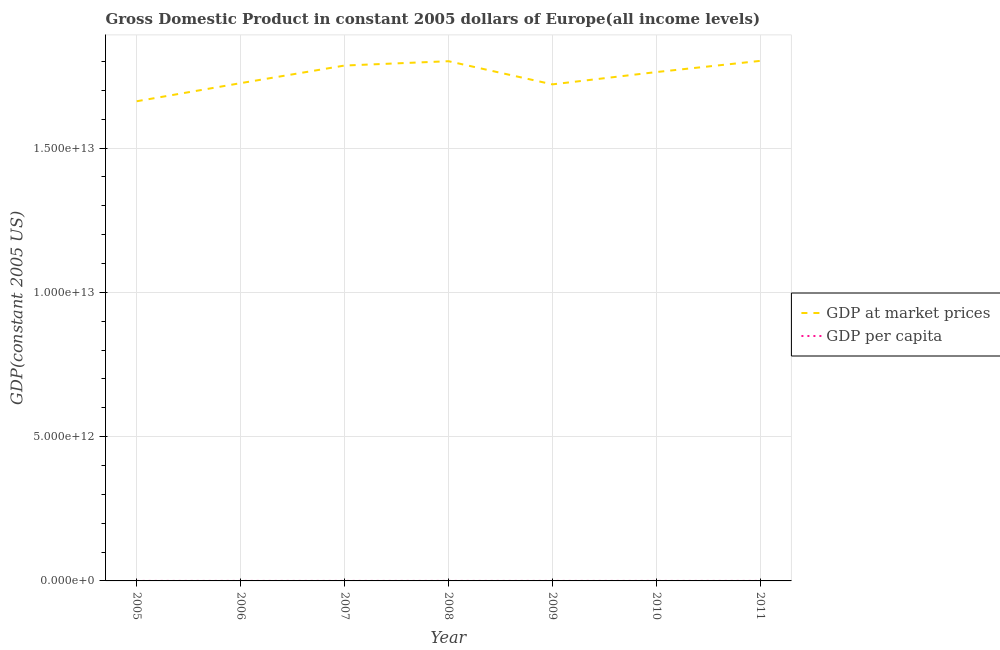How many different coloured lines are there?
Your response must be concise. 2. What is the gdp at market prices in 2008?
Offer a terse response. 1.80e+13. Across all years, what is the maximum gdp per capita?
Provide a short and direct response. 2.04e+04. Across all years, what is the minimum gdp per capita?
Offer a very short reply. 1.90e+04. In which year was the gdp per capita maximum?
Provide a succinct answer. 2008. In which year was the gdp at market prices minimum?
Offer a terse response. 2005. What is the total gdp per capita in the graph?
Offer a terse response. 1.39e+05. What is the difference between the gdp per capita in 2009 and that in 2011?
Your answer should be compact. -758.73. What is the difference between the gdp per capita in 2010 and the gdp at market prices in 2011?
Offer a very short reply. -1.80e+13. What is the average gdp per capita per year?
Make the answer very short. 1.98e+04. In the year 2005, what is the difference between the gdp per capita and gdp at market prices?
Ensure brevity in your answer.  -1.66e+13. In how many years, is the gdp at market prices greater than 7000000000000 US$?
Keep it short and to the point. 7. What is the ratio of the gdp at market prices in 2005 to that in 2010?
Your answer should be compact. 0.94. Is the gdp per capita in 2007 less than that in 2008?
Make the answer very short. Yes. What is the difference between the highest and the second highest gdp at market prices?
Ensure brevity in your answer.  1.16e+1. What is the difference between the highest and the lowest gdp at market prices?
Make the answer very short. 1.40e+12. Is the gdp at market prices strictly greater than the gdp per capita over the years?
Your answer should be compact. Yes. Is the gdp per capita strictly less than the gdp at market prices over the years?
Keep it short and to the point. Yes. How many years are there in the graph?
Your response must be concise. 7. What is the difference between two consecutive major ticks on the Y-axis?
Provide a succinct answer. 5.00e+12. Where does the legend appear in the graph?
Provide a succinct answer. Center right. What is the title of the graph?
Your answer should be very brief. Gross Domestic Product in constant 2005 dollars of Europe(all income levels). Does "Imports" appear as one of the legend labels in the graph?
Give a very brief answer. No. What is the label or title of the X-axis?
Your response must be concise. Year. What is the label or title of the Y-axis?
Your answer should be compact. GDP(constant 2005 US). What is the GDP(constant 2005 US) of GDP at market prices in 2005?
Offer a very short reply. 1.66e+13. What is the GDP(constant 2005 US) of GDP per capita in 2005?
Make the answer very short. 1.90e+04. What is the GDP(constant 2005 US) of GDP at market prices in 2006?
Give a very brief answer. 1.73e+13. What is the GDP(constant 2005 US) in GDP per capita in 2006?
Your answer should be very brief. 1.97e+04. What is the GDP(constant 2005 US) of GDP at market prices in 2007?
Your answer should be very brief. 1.79e+13. What is the GDP(constant 2005 US) in GDP per capita in 2007?
Keep it short and to the point. 2.03e+04. What is the GDP(constant 2005 US) of GDP at market prices in 2008?
Your answer should be compact. 1.80e+13. What is the GDP(constant 2005 US) in GDP per capita in 2008?
Offer a terse response. 2.04e+04. What is the GDP(constant 2005 US) of GDP at market prices in 2009?
Your answer should be compact. 1.72e+13. What is the GDP(constant 2005 US) of GDP per capita in 2009?
Provide a succinct answer. 1.94e+04. What is the GDP(constant 2005 US) of GDP at market prices in 2010?
Your answer should be compact. 1.76e+13. What is the GDP(constant 2005 US) of GDP per capita in 2010?
Keep it short and to the point. 1.98e+04. What is the GDP(constant 2005 US) of GDP at market prices in 2011?
Your answer should be very brief. 1.80e+13. What is the GDP(constant 2005 US) of GDP per capita in 2011?
Make the answer very short. 2.02e+04. Across all years, what is the maximum GDP(constant 2005 US) in GDP at market prices?
Offer a very short reply. 1.80e+13. Across all years, what is the maximum GDP(constant 2005 US) of GDP per capita?
Ensure brevity in your answer.  2.04e+04. Across all years, what is the minimum GDP(constant 2005 US) in GDP at market prices?
Offer a terse response. 1.66e+13. Across all years, what is the minimum GDP(constant 2005 US) of GDP per capita?
Keep it short and to the point. 1.90e+04. What is the total GDP(constant 2005 US) of GDP at market prices in the graph?
Offer a terse response. 1.23e+14. What is the total GDP(constant 2005 US) of GDP per capita in the graph?
Offer a terse response. 1.39e+05. What is the difference between the GDP(constant 2005 US) of GDP at market prices in 2005 and that in 2006?
Provide a succinct answer. -6.28e+11. What is the difference between the GDP(constant 2005 US) in GDP per capita in 2005 and that in 2006?
Your response must be concise. -656.02. What is the difference between the GDP(constant 2005 US) of GDP at market prices in 2005 and that in 2007?
Offer a terse response. -1.24e+12. What is the difference between the GDP(constant 2005 US) of GDP per capita in 2005 and that in 2007?
Your response must be concise. -1281.47. What is the difference between the GDP(constant 2005 US) of GDP at market prices in 2005 and that in 2008?
Make the answer very short. -1.39e+12. What is the difference between the GDP(constant 2005 US) of GDP per capita in 2005 and that in 2008?
Offer a terse response. -1369.71. What is the difference between the GDP(constant 2005 US) of GDP at market prices in 2005 and that in 2009?
Provide a short and direct response. -5.85e+11. What is the difference between the GDP(constant 2005 US) of GDP per capita in 2005 and that in 2009?
Provide a short and direct response. -378.62. What is the difference between the GDP(constant 2005 US) of GDP at market prices in 2005 and that in 2010?
Your answer should be very brief. -1.01e+12. What is the difference between the GDP(constant 2005 US) of GDP per capita in 2005 and that in 2010?
Your answer should be very brief. -780.19. What is the difference between the GDP(constant 2005 US) of GDP at market prices in 2005 and that in 2011?
Your answer should be very brief. -1.40e+12. What is the difference between the GDP(constant 2005 US) of GDP per capita in 2005 and that in 2011?
Your answer should be very brief. -1137.34. What is the difference between the GDP(constant 2005 US) in GDP at market prices in 2006 and that in 2007?
Your response must be concise. -6.10e+11. What is the difference between the GDP(constant 2005 US) of GDP per capita in 2006 and that in 2007?
Offer a very short reply. -625.44. What is the difference between the GDP(constant 2005 US) of GDP at market prices in 2006 and that in 2008?
Give a very brief answer. -7.60e+11. What is the difference between the GDP(constant 2005 US) of GDP per capita in 2006 and that in 2008?
Provide a succinct answer. -713.69. What is the difference between the GDP(constant 2005 US) in GDP at market prices in 2006 and that in 2009?
Your answer should be very brief. 4.28e+1. What is the difference between the GDP(constant 2005 US) in GDP per capita in 2006 and that in 2009?
Make the answer very short. 277.41. What is the difference between the GDP(constant 2005 US) in GDP at market prices in 2006 and that in 2010?
Provide a short and direct response. -3.84e+11. What is the difference between the GDP(constant 2005 US) of GDP per capita in 2006 and that in 2010?
Keep it short and to the point. -124.16. What is the difference between the GDP(constant 2005 US) of GDP at market prices in 2006 and that in 2011?
Make the answer very short. -7.71e+11. What is the difference between the GDP(constant 2005 US) in GDP per capita in 2006 and that in 2011?
Your answer should be very brief. -481.32. What is the difference between the GDP(constant 2005 US) of GDP at market prices in 2007 and that in 2008?
Keep it short and to the point. -1.50e+11. What is the difference between the GDP(constant 2005 US) of GDP per capita in 2007 and that in 2008?
Offer a terse response. -88.25. What is the difference between the GDP(constant 2005 US) of GDP at market prices in 2007 and that in 2009?
Keep it short and to the point. 6.53e+11. What is the difference between the GDP(constant 2005 US) in GDP per capita in 2007 and that in 2009?
Offer a very short reply. 902.85. What is the difference between the GDP(constant 2005 US) in GDP at market prices in 2007 and that in 2010?
Provide a succinct answer. 2.26e+11. What is the difference between the GDP(constant 2005 US) in GDP per capita in 2007 and that in 2010?
Offer a terse response. 501.28. What is the difference between the GDP(constant 2005 US) in GDP at market prices in 2007 and that in 2011?
Keep it short and to the point. -1.61e+11. What is the difference between the GDP(constant 2005 US) in GDP per capita in 2007 and that in 2011?
Your response must be concise. 144.12. What is the difference between the GDP(constant 2005 US) of GDP at market prices in 2008 and that in 2009?
Offer a very short reply. 8.03e+11. What is the difference between the GDP(constant 2005 US) in GDP per capita in 2008 and that in 2009?
Your answer should be compact. 991.1. What is the difference between the GDP(constant 2005 US) of GDP at market prices in 2008 and that in 2010?
Your answer should be compact. 3.76e+11. What is the difference between the GDP(constant 2005 US) of GDP per capita in 2008 and that in 2010?
Provide a short and direct response. 589.53. What is the difference between the GDP(constant 2005 US) in GDP at market prices in 2008 and that in 2011?
Offer a very short reply. -1.16e+1. What is the difference between the GDP(constant 2005 US) in GDP per capita in 2008 and that in 2011?
Your response must be concise. 232.37. What is the difference between the GDP(constant 2005 US) in GDP at market prices in 2009 and that in 2010?
Offer a terse response. -4.27e+11. What is the difference between the GDP(constant 2005 US) of GDP per capita in 2009 and that in 2010?
Your answer should be compact. -401.57. What is the difference between the GDP(constant 2005 US) in GDP at market prices in 2009 and that in 2011?
Ensure brevity in your answer.  -8.14e+11. What is the difference between the GDP(constant 2005 US) in GDP per capita in 2009 and that in 2011?
Make the answer very short. -758.73. What is the difference between the GDP(constant 2005 US) in GDP at market prices in 2010 and that in 2011?
Offer a terse response. -3.88e+11. What is the difference between the GDP(constant 2005 US) in GDP per capita in 2010 and that in 2011?
Give a very brief answer. -357.16. What is the difference between the GDP(constant 2005 US) of GDP at market prices in 2005 and the GDP(constant 2005 US) of GDP per capita in 2006?
Provide a short and direct response. 1.66e+13. What is the difference between the GDP(constant 2005 US) of GDP at market prices in 2005 and the GDP(constant 2005 US) of GDP per capita in 2007?
Keep it short and to the point. 1.66e+13. What is the difference between the GDP(constant 2005 US) of GDP at market prices in 2005 and the GDP(constant 2005 US) of GDP per capita in 2008?
Your answer should be compact. 1.66e+13. What is the difference between the GDP(constant 2005 US) in GDP at market prices in 2005 and the GDP(constant 2005 US) in GDP per capita in 2009?
Provide a short and direct response. 1.66e+13. What is the difference between the GDP(constant 2005 US) of GDP at market prices in 2005 and the GDP(constant 2005 US) of GDP per capita in 2010?
Provide a short and direct response. 1.66e+13. What is the difference between the GDP(constant 2005 US) of GDP at market prices in 2005 and the GDP(constant 2005 US) of GDP per capita in 2011?
Your answer should be compact. 1.66e+13. What is the difference between the GDP(constant 2005 US) in GDP at market prices in 2006 and the GDP(constant 2005 US) in GDP per capita in 2007?
Make the answer very short. 1.73e+13. What is the difference between the GDP(constant 2005 US) in GDP at market prices in 2006 and the GDP(constant 2005 US) in GDP per capita in 2008?
Your answer should be compact. 1.73e+13. What is the difference between the GDP(constant 2005 US) in GDP at market prices in 2006 and the GDP(constant 2005 US) in GDP per capita in 2009?
Provide a short and direct response. 1.73e+13. What is the difference between the GDP(constant 2005 US) in GDP at market prices in 2006 and the GDP(constant 2005 US) in GDP per capita in 2010?
Provide a succinct answer. 1.73e+13. What is the difference between the GDP(constant 2005 US) in GDP at market prices in 2006 and the GDP(constant 2005 US) in GDP per capita in 2011?
Ensure brevity in your answer.  1.73e+13. What is the difference between the GDP(constant 2005 US) in GDP at market prices in 2007 and the GDP(constant 2005 US) in GDP per capita in 2008?
Give a very brief answer. 1.79e+13. What is the difference between the GDP(constant 2005 US) of GDP at market prices in 2007 and the GDP(constant 2005 US) of GDP per capita in 2009?
Keep it short and to the point. 1.79e+13. What is the difference between the GDP(constant 2005 US) in GDP at market prices in 2007 and the GDP(constant 2005 US) in GDP per capita in 2010?
Ensure brevity in your answer.  1.79e+13. What is the difference between the GDP(constant 2005 US) in GDP at market prices in 2007 and the GDP(constant 2005 US) in GDP per capita in 2011?
Keep it short and to the point. 1.79e+13. What is the difference between the GDP(constant 2005 US) in GDP at market prices in 2008 and the GDP(constant 2005 US) in GDP per capita in 2009?
Offer a very short reply. 1.80e+13. What is the difference between the GDP(constant 2005 US) in GDP at market prices in 2008 and the GDP(constant 2005 US) in GDP per capita in 2010?
Offer a very short reply. 1.80e+13. What is the difference between the GDP(constant 2005 US) in GDP at market prices in 2008 and the GDP(constant 2005 US) in GDP per capita in 2011?
Keep it short and to the point. 1.80e+13. What is the difference between the GDP(constant 2005 US) of GDP at market prices in 2009 and the GDP(constant 2005 US) of GDP per capita in 2010?
Your answer should be very brief. 1.72e+13. What is the difference between the GDP(constant 2005 US) in GDP at market prices in 2009 and the GDP(constant 2005 US) in GDP per capita in 2011?
Provide a short and direct response. 1.72e+13. What is the difference between the GDP(constant 2005 US) of GDP at market prices in 2010 and the GDP(constant 2005 US) of GDP per capita in 2011?
Offer a very short reply. 1.76e+13. What is the average GDP(constant 2005 US) in GDP at market prices per year?
Give a very brief answer. 1.75e+13. What is the average GDP(constant 2005 US) in GDP per capita per year?
Provide a succinct answer. 1.98e+04. In the year 2005, what is the difference between the GDP(constant 2005 US) of GDP at market prices and GDP(constant 2005 US) of GDP per capita?
Your answer should be very brief. 1.66e+13. In the year 2006, what is the difference between the GDP(constant 2005 US) in GDP at market prices and GDP(constant 2005 US) in GDP per capita?
Your answer should be very brief. 1.73e+13. In the year 2007, what is the difference between the GDP(constant 2005 US) of GDP at market prices and GDP(constant 2005 US) of GDP per capita?
Your answer should be very brief. 1.79e+13. In the year 2008, what is the difference between the GDP(constant 2005 US) of GDP at market prices and GDP(constant 2005 US) of GDP per capita?
Ensure brevity in your answer.  1.80e+13. In the year 2009, what is the difference between the GDP(constant 2005 US) in GDP at market prices and GDP(constant 2005 US) in GDP per capita?
Make the answer very short. 1.72e+13. In the year 2010, what is the difference between the GDP(constant 2005 US) of GDP at market prices and GDP(constant 2005 US) of GDP per capita?
Keep it short and to the point. 1.76e+13. In the year 2011, what is the difference between the GDP(constant 2005 US) in GDP at market prices and GDP(constant 2005 US) in GDP per capita?
Your response must be concise. 1.80e+13. What is the ratio of the GDP(constant 2005 US) in GDP at market prices in 2005 to that in 2006?
Your answer should be very brief. 0.96. What is the ratio of the GDP(constant 2005 US) in GDP per capita in 2005 to that in 2006?
Offer a very short reply. 0.97. What is the ratio of the GDP(constant 2005 US) of GDP at market prices in 2005 to that in 2007?
Provide a succinct answer. 0.93. What is the ratio of the GDP(constant 2005 US) in GDP per capita in 2005 to that in 2007?
Your answer should be compact. 0.94. What is the ratio of the GDP(constant 2005 US) of GDP at market prices in 2005 to that in 2008?
Offer a terse response. 0.92. What is the ratio of the GDP(constant 2005 US) in GDP per capita in 2005 to that in 2008?
Offer a terse response. 0.93. What is the ratio of the GDP(constant 2005 US) in GDP at market prices in 2005 to that in 2009?
Provide a short and direct response. 0.97. What is the ratio of the GDP(constant 2005 US) of GDP per capita in 2005 to that in 2009?
Your response must be concise. 0.98. What is the ratio of the GDP(constant 2005 US) of GDP at market prices in 2005 to that in 2010?
Offer a terse response. 0.94. What is the ratio of the GDP(constant 2005 US) in GDP per capita in 2005 to that in 2010?
Your response must be concise. 0.96. What is the ratio of the GDP(constant 2005 US) of GDP at market prices in 2005 to that in 2011?
Provide a succinct answer. 0.92. What is the ratio of the GDP(constant 2005 US) in GDP per capita in 2005 to that in 2011?
Keep it short and to the point. 0.94. What is the ratio of the GDP(constant 2005 US) of GDP at market prices in 2006 to that in 2007?
Give a very brief answer. 0.97. What is the ratio of the GDP(constant 2005 US) of GDP per capita in 2006 to that in 2007?
Ensure brevity in your answer.  0.97. What is the ratio of the GDP(constant 2005 US) in GDP at market prices in 2006 to that in 2008?
Ensure brevity in your answer.  0.96. What is the ratio of the GDP(constant 2005 US) in GDP at market prices in 2006 to that in 2009?
Offer a very short reply. 1. What is the ratio of the GDP(constant 2005 US) of GDP per capita in 2006 to that in 2009?
Give a very brief answer. 1.01. What is the ratio of the GDP(constant 2005 US) in GDP at market prices in 2006 to that in 2010?
Provide a short and direct response. 0.98. What is the ratio of the GDP(constant 2005 US) of GDP at market prices in 2006 to that in 2011?
Your answer should be very brief. 0.96. What is the ratio of the GDP(constant 2005 US) in GDP per capita in 2006 to that in 2011?
Offer a terse response. 0.98. What is the ratio of the GDP(constant 2005 US) in GDP per capita in 2007 to that in 2008?
Keep it short and to the point. 1. What is the ratio of the GDP(constant 2005 US) of GDP at market prices in 2007 to that in 2009?
Your response must be concise. 1.04. What is the ratio of the GDP(constant 2005 US) of GDP per capita in 2007 to that in 2009?
Ensure brevity in your answer.  1.05. What is the ratio of the GDP(constant 2005 US) in GDP at market prices in 2007 to that in 2010?
Keep it short and to the point. 1.01. What is the ratio of the GDP(constant 2005 US) in GDP per capita in 2007 to that in 2010?
Offer a very short reply. 1.03. What is the ratio of the GDP(constant 2005 US) in GDP per capita in 2007 to that in 2011?
Provide a succinct answer. 1.01. What is the ratio of the GDP(constant 2005 US) in GDP at market prices in 2008 to that in 2009?
Offer a terse response. 1.05. What is the ratio of the GDP(constant 2005 US) of GDP per capita in 2008 to that in 2009?
Ensure brevity in your answer.  1.05. What is the ratio of the GDP(constant 2005 US) in GDP at market prices in 2008 to that in 2010?
Your answer should be very brief. 1.02. What is the ratio of the GDP(constant 2005 US) in GDP per capita in 2008 to that in 2010?
Your answer should be very brief. 1.03. What is the ratio of the GDP(constant 2005 US) in GDP per capita in 2008 to that in 2011?
Your answer should be compact. 1.01. What is the ratio of the GDP(constant 2005 US) in GDP at market prices in 2009 to that in 2010?
Your answer should be very brief. 0.98. What is the ratio of the GDP(constant 2005 US) in GDP per capita in 2009 to that in 2010?
Provide a succinct answer. 0.98. What is the ratio of the GDP(constant 2005 US) in GDP at market prices in 2009 to that in 2011?
Provide a succinct answer. 0.95. What is the ratio of the GDP(constant 2005 US) in GDP per capita in 2009 to that in 2011?
Make the answer very short. 0.96. What is the ratio of the GDP(constant 2005 US) of GDP at market prices in 2010 to that in 2011?
Offer a very short reply. 0.98. What is the ratio of the GDP(constant 2005 US) in GDP per capita in 2010 to that in 2011?
Keep it short and to the point. 0.98. What is the difference between the highest and the second highest GDP(constant 2005 US) of GDP at market prices?
Ensure brevity in your answer.  1.16e+1. What is the difference between the highest and the second highest GDP(constant 2005 US) in GDP per capita?
Ensure brevity in your answer.  88.25. What is the difference between the highest and the lowest GDP(constant 2005 US) in GDP at market prices?
Make the answer very short. 1.40e+12. What is the difference between the highest and the lowest GDP(constant 2005 US) in GDP per capita?
Ensure brevity in your answer.  1369.71. 